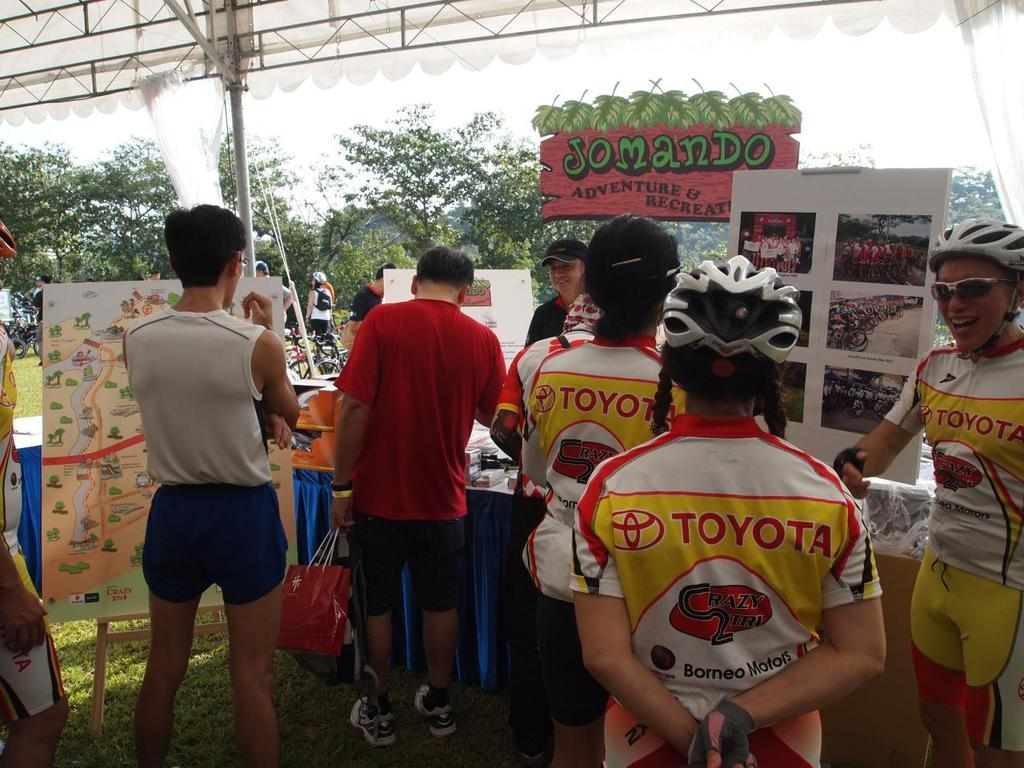<image>
Share a concise interpretation of the image provided. A Jomando sign stands over a group of people in Toyota shirts. 